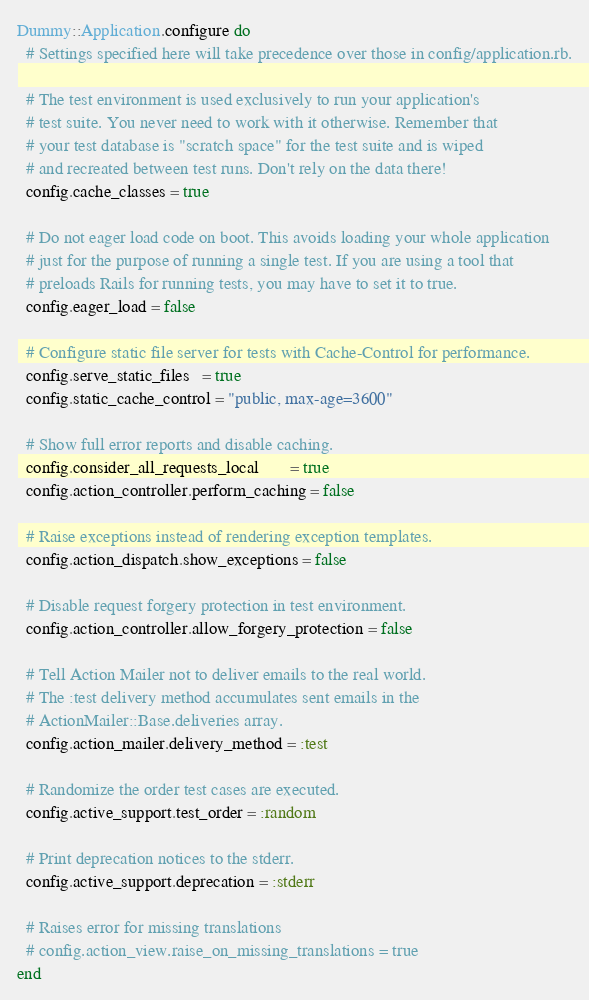<code> <loc_0><loc_0><loc_500><loc_500><_Ruby_>Dummy::Application.configure do
  # Settings specified here will take precedence over those in config/application.rb.

  # The test environment is used exclusively to run your application's
  # test suite. You never need to work with it otherwise. Remember that
  # your test database is "scratch space" for the test suite and is wiped
  # and recreated between test runs. Don't rely on the data there!
  config.cache_classes = true

  # Do not eager load code on boot. This avoids loading your whole application
  # just for the purpose of running a single test. If you are using a tool that
  # preloads Rails for running tests, you may have to set it to true.
  config.eager_load = false

  # Configure static file server for tests with Cache-Control for performance.
  config.serve_static_files   = true
  config.static_cache_control = "public, max-age=3600"

  # Show full error reports and disable caching.
  config.consider_all_requests_local       = true
  config.action_controller.perform_caching = false

  # Raise exceptions instead of rendering exception templates.
  config.action_dispatch.show_exceptions = false

  # Disable request forgery protection in test environment.
  config.action_controller.allow_forgery_protection = false

  # Tell Action Mailer not to deliver emails to the real world.
  # The :test delivery method accumulates sent emails in the
  # ActionMailer::Base.deliveries array.
  config.action_mailer.delivery_method = :test

  # Randomize the order test cases are executed.
  config.active_support.test_order = :random

  # Print deprecation notices to the stderr.
  config.active_support.deprecation = :stderr

  # Raises error for missing translations
  # config.action_view.raise_on_missing_translations = true
end
</code> 